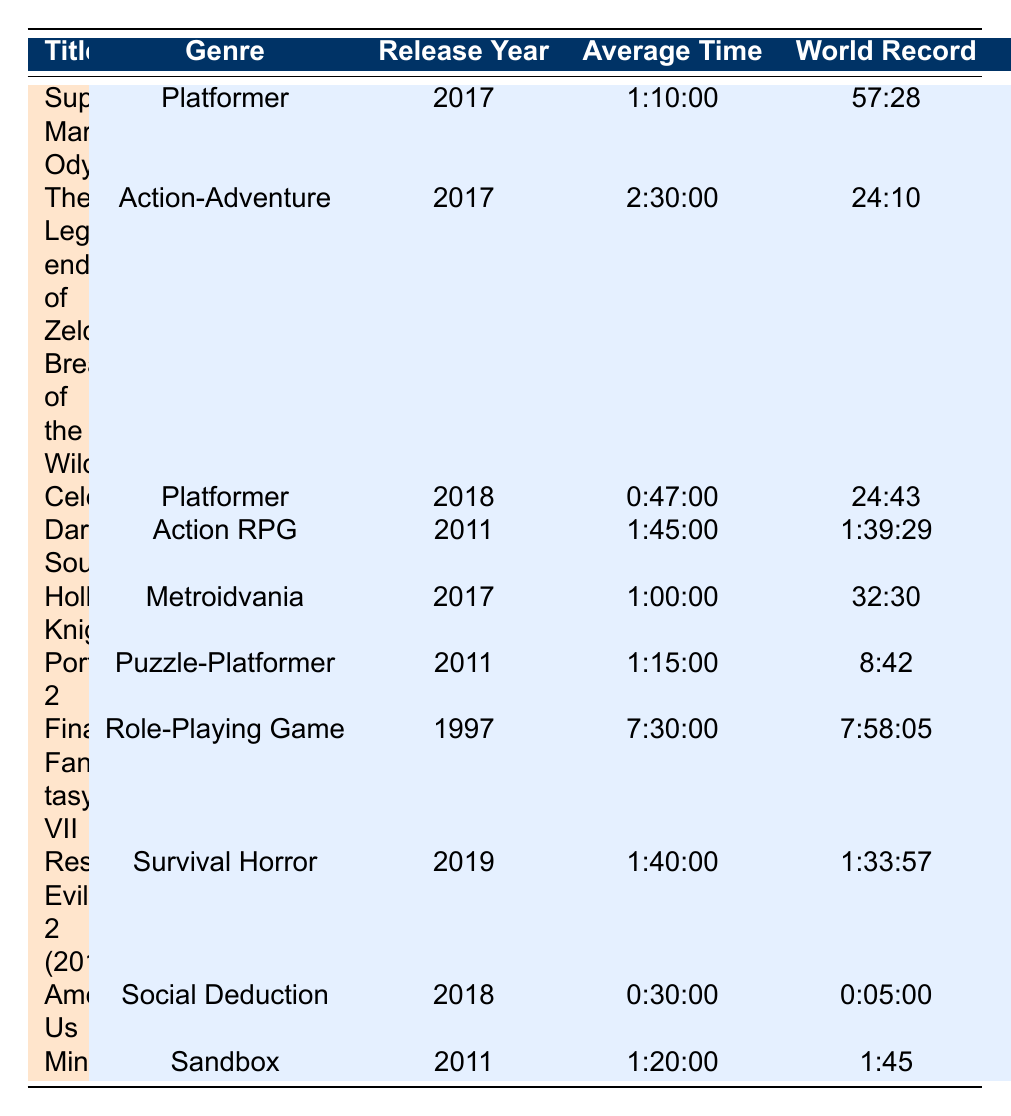What is the genre of "Celeste"? The table lists "Celeste" under the genre column, which indicates that it is categorized as a Platformer.
Answer: Platformer Which game has the longest average speedrun time? By comparing the average times listed, "Final Fantasy VII" with an average time of 7:30:00 is the longest.
Answer: Final Fantasy VII How many games released in 2017 are in the speedrunning community? The table lists games released in 2017: "Super Mario Odyssey," "The Legend of Zelda: Breath of the Wild," "Hollow Knight," totaling three games.
Answer: 3 What is the difference between the world record and average time for "Hollow Knight"? The average time for "Hollow Knight" is 1:00:00, and the world record is 32:30. To find the difference, we convert both into the same format: 1:00:00 is 60 minutes and 32:30 is 32.5 minutes. The difference is 60 - 32.5 = 27.5 minutes or 0:27:30.
Answer: 0:27:30 Is "Among Us" an Action RPG? Looking at the genre column for the game "Among Us," it is categorized as Social Deduction, which means it is not an Action RPG.
Answer: No Which genre has the most games listed? By counting the genre occurrences, Platformer appears twice ("Super Mario Odyssey" and "Celeste"), which is the highest count among all genres.
Answer: Platformer What is the average estimate count for games released in 2011? The games released in 2011 are "Dark Souls," "Portal 2," and "Minecraft" with estimate counts of 1300, 600, and 1000, respectively. The sum is 1300 + 600 + 1000 = 2900. To find the average, we divide by 3: 2900 / 3 = 966.67 or approximately 967.
Answer: 967 Is "Resident Evil 2 (2019)" faster than "Final Fantasy VII" based on world records? Comparing their world records, "Resident Evil 2 (2019)" has a world record of 1:33:57, while "Final Fantasy VII" has a world record of 7:58:05. Since 1:33:57 is less than 7:58:05, "Resident Evil 2 (2019)" is faster.
Answer: Yes 